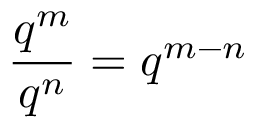Convert formula to latex. <formula><loc_0><loc_0><loc_500><loc_500>{ \frac { q ^ { m } } { q ^ { n } } } = q ^ { m - n }</formula> 